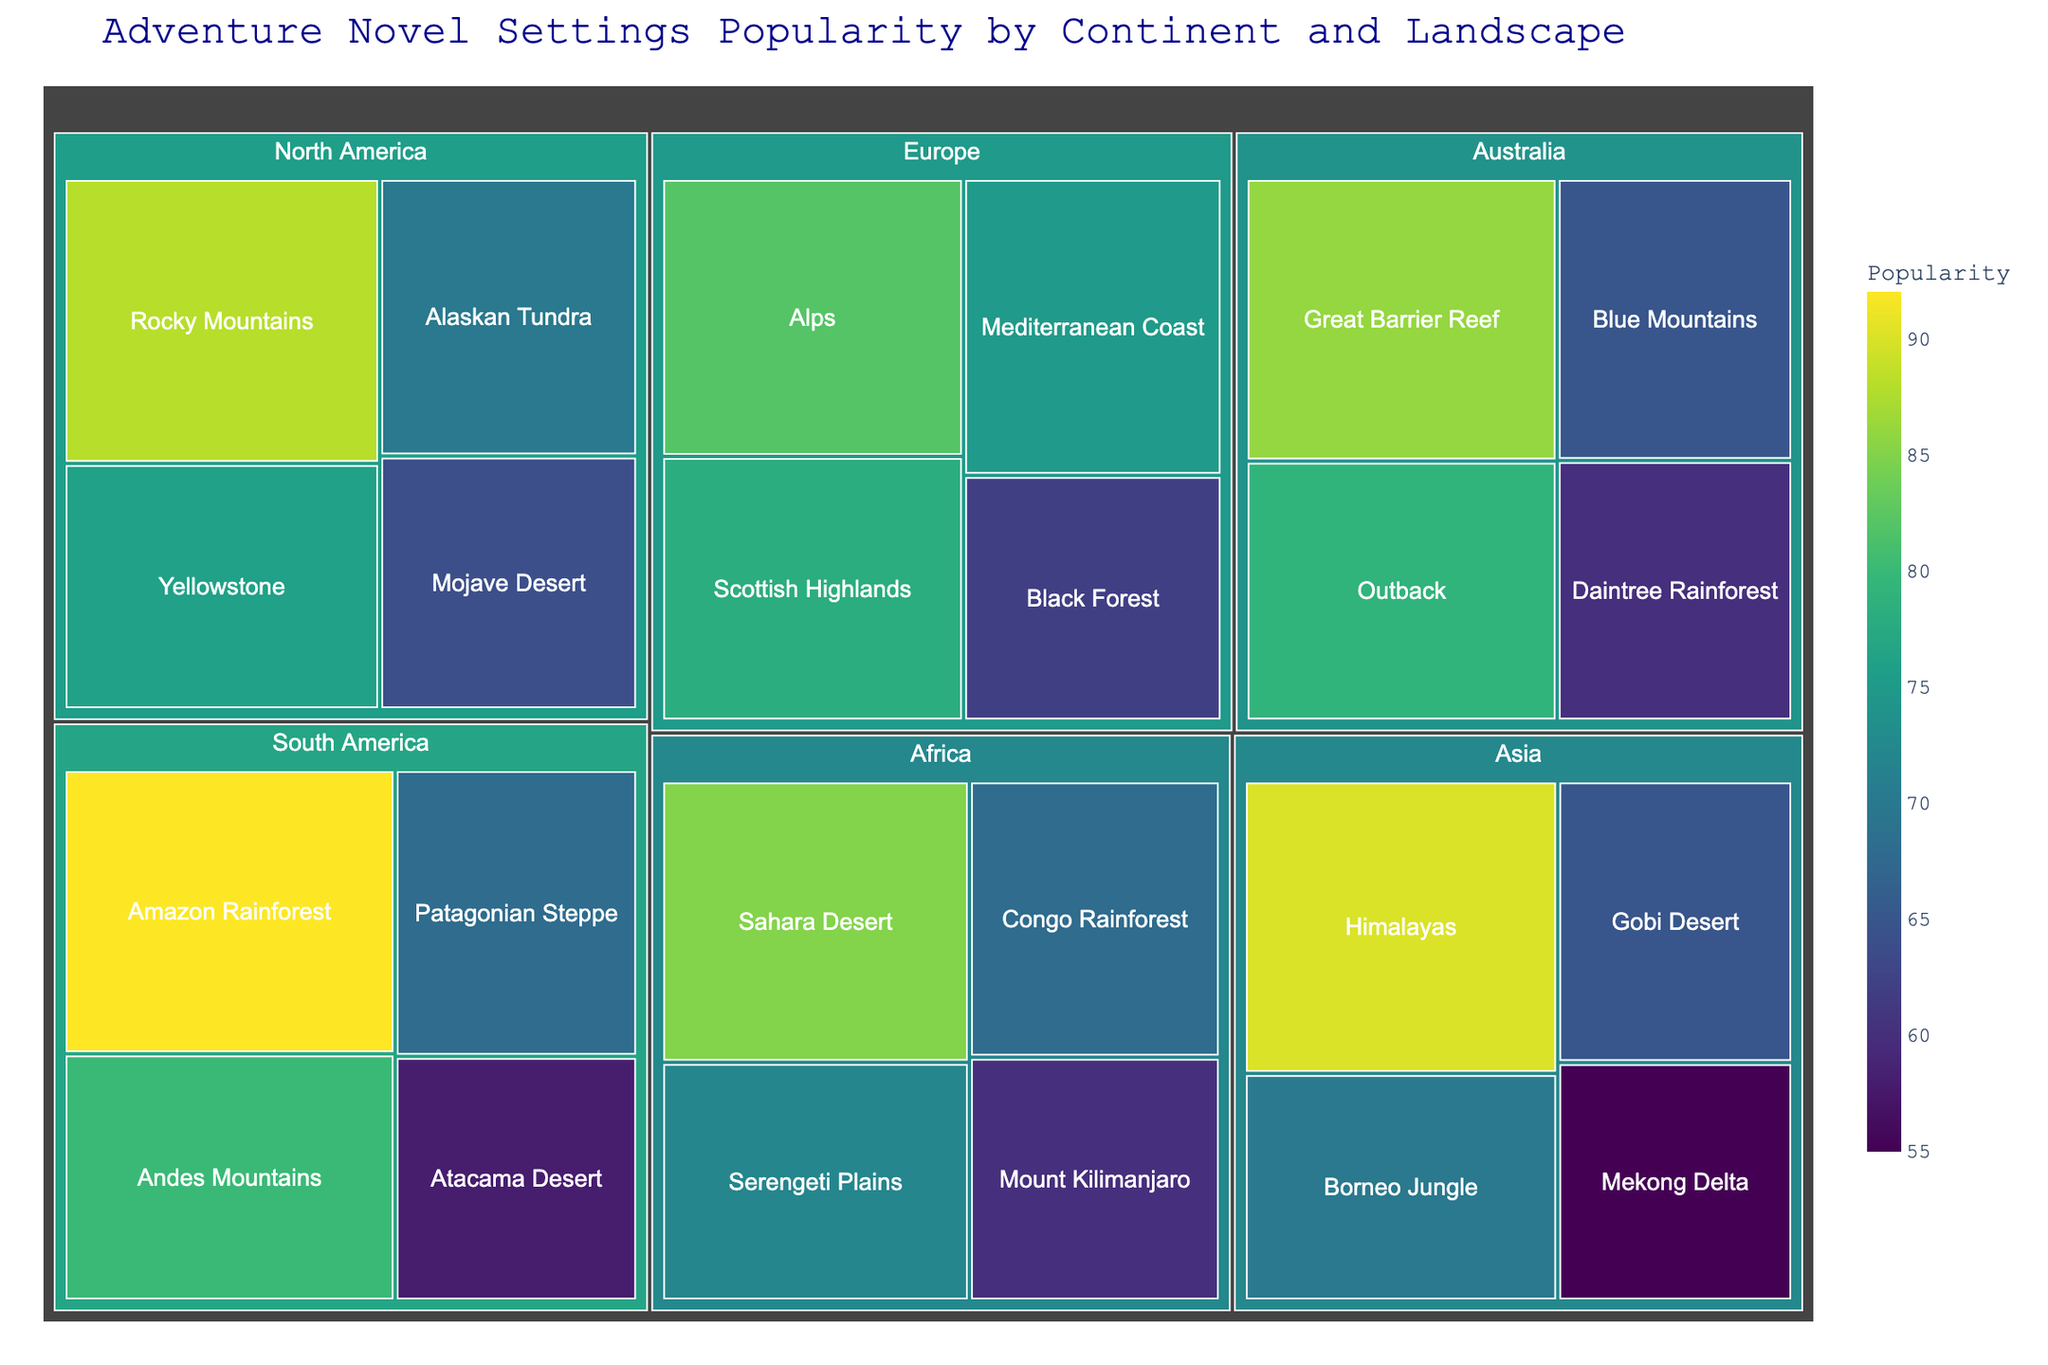How many landscapes are shown for the continent Africa? Notice the treemap displaying different landscapes under the Africa category. Count each distinct landscape listed.
Answer: 4 Which continent has the most popular landscape overall? Identify the landscape with the highest popularity value and see which continent it belongs to. The Amazon Rainforest has a popularity value of 92, the highest in the dataset.
Answer: South America What is the combined popularity of all landscapes in North America? Sum up the popularity values of all landscapes in the North America section: Rocky Mountains (88) + Yellowstone (76) + Alaskan Tundra (70) + Mojave Desert (64).
Answer: 298 Which two landscapes have the closest popularity values and what are they? Compare the popularity values visually and find the two closest ones. The Scottish Highlands (78) and Yellowstone (76) have values that are close together.
Answer: Scottish Highlands, Yellowstone Is the popularity of the Sahara Desert higher or lower than the Patagonian Steppe? Compare the popularity values of Sahara Desert (85) and Patagonian Steppe (68).
Answer: Higher Which landscape is the least popular in Asia? Look at the listed landscapes under Asia and identify the one with the smallest value. The Mekong Delta has the lowest popularity value of 55.
Answer: Mekong Delta What is the average popularity of landscapes in Europe? Sum the popularity values of landscapes in Europe and divide by the number of landscapes: (78 + 82 + 75 + 62) / 4.
Answer: 74.25 Rank the continents based on their most popular landscape from most popular to least popular. Identify the most popular landscape for each continent, rank them based on these values: South America (Amazon Rainforest, 92), Asia (Himalayas, 90), North America (Rocky Mountains, 88), Australia (Great Barrier Reef, 86), Africa (Sahara Desert, 85), Europe (Alps, 82).
Answer: South America, Asia, North America, Australia, Africa, Europe Which continent has the least variation in landscape popularity? Determine the range (difference between highest and lowest popularity values) for each continent and find the smallest range. Europe has a range of 82 - 62 = 20.
Answer: Europe 